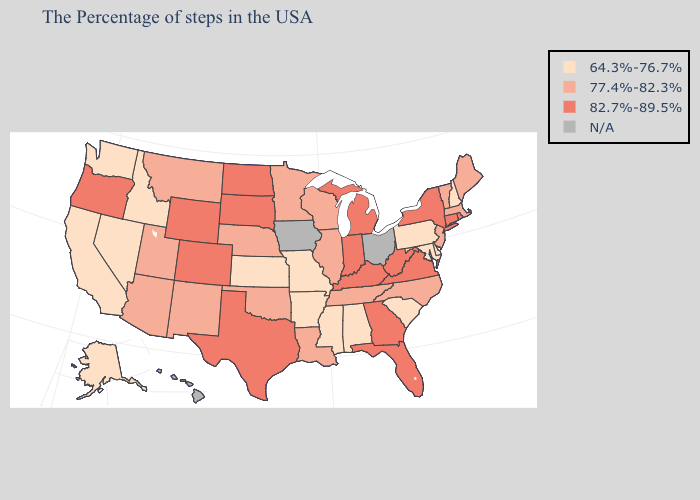Name the states that have a value in the range 64.3%-76.7%?
Keep it brief. New Hampshire, Delaware, Maryland, Pennsylvania, South Carolina, Alabama, Mississippi, Missouri, Arkansas, Kansas, Idaho, Nevada, California, Washington, Alaska. Name the states that have a value in the range 82.7%-89.5%?
Concise answer only. Rhode Island, Connecticut, New York, Virginia, West Virginia, Florida, Georgia, Michigan, Kentucky, Indiana, Texas, South Dakota, North Dakota, Wyoming, Colorado, Oregon. Does Texas have the highest value in the USA?
Give a very brief answer. Yes. Among the states that border Wisconsin , which have the lowest value?
Be succinct. Illinois, Minnesota. Which states have the lowest value in the USA?
Concise answer only. New Hampshire, Delaware, Maryland, Pennsylvania, South Carolina, Alabama, Mississippi, Missouri, Arkansas, Kansas, Idaho, Nevada, California, Washington, Alaska. Among the states that border Virginia , does Tennessee have the highest value?
Give a very brief answer. No. What is the value of South Dakota?
Short answer required. 82.7%-89.5%. Does the first symbol in the legend represent the smallest category?
Keep it brief. Yes. Which states hav the highest value in the Northeast?
Short answer required. Rhode Island, Connecticut, New York. Does Texas have the lowest value in the South?
Answer briefly. No. What is the value of Oklahoma?
Short answer required. 77.4%-82.3%. What is the value of North Carolina?
Keep it brief. 77.4%-82.3%. What is the value of Alaska?
Concise answer only. 64.3%-76.7%. Among the states that border Georgia , does Florida have the lowest value?
Write a very short answer. No. Name the states that have a value in the range 77.4%-82.3%?
Short answer required. Maine, Massachusetts, Vermont, New Jersey, North Carolina, Tennessee, Wisconsin, Illinois, Louisiana, Minnesota, Nebraska, Oklahoma, New Mexico, Utah, Montana, Arizona. 